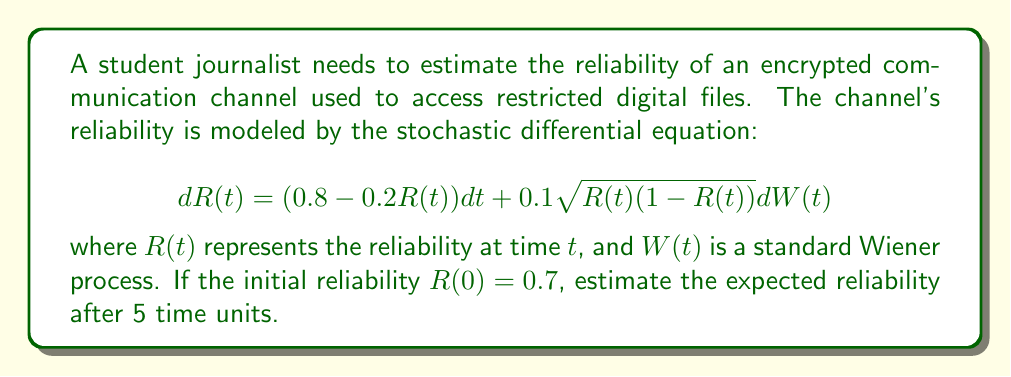Can you answer this question? To estimate the expected reliability, we need to solve the stochastic differential equation (SDE) for its expected value. The steps are as follows:

1) The general form of this SDE is:
   $$dR(t) = a(R,t)dt + b(R,t)dW(t)$$
   where $a(R,t) = 0.8 - 0.2R(t)$ and $b(R,t) = 0.1\sqrt{R(t)(1-R(t))}$

2) For the expected value, we only need to consider the drift term $a(R,t)$:
   $$\frac{d\mathbb{E}[R(t)]}{dt} = \mathbb{E}[a(R,t)] = 0.8 - 0.2\mathbb{E}[R(t)]$$

3) Let $m(t) = \mathbb{E}[R(t)]$. Then we have the ordinary differential equation:
   $$\frac{dm(t)}{dt} = 0.8 - 0.2m(t)$$

4) This is a linear first-order ODE. The solution is:
   $$m(t) = 4 + (m(0) - 4)e^{-0.2t}$$

5) Given $R(0) = 0.7$, we have $m(0) = 0.7$. Substituting this and $t = 5$:
   $$m(5) = 4 + (0.7 - 4)e^{-0.2(5)} = 4 - 3.3e^{-1} \approx 2.78$$

Therefore, the expected reliability after 5 time units is approximately 2.78.
Answer: 2.78 